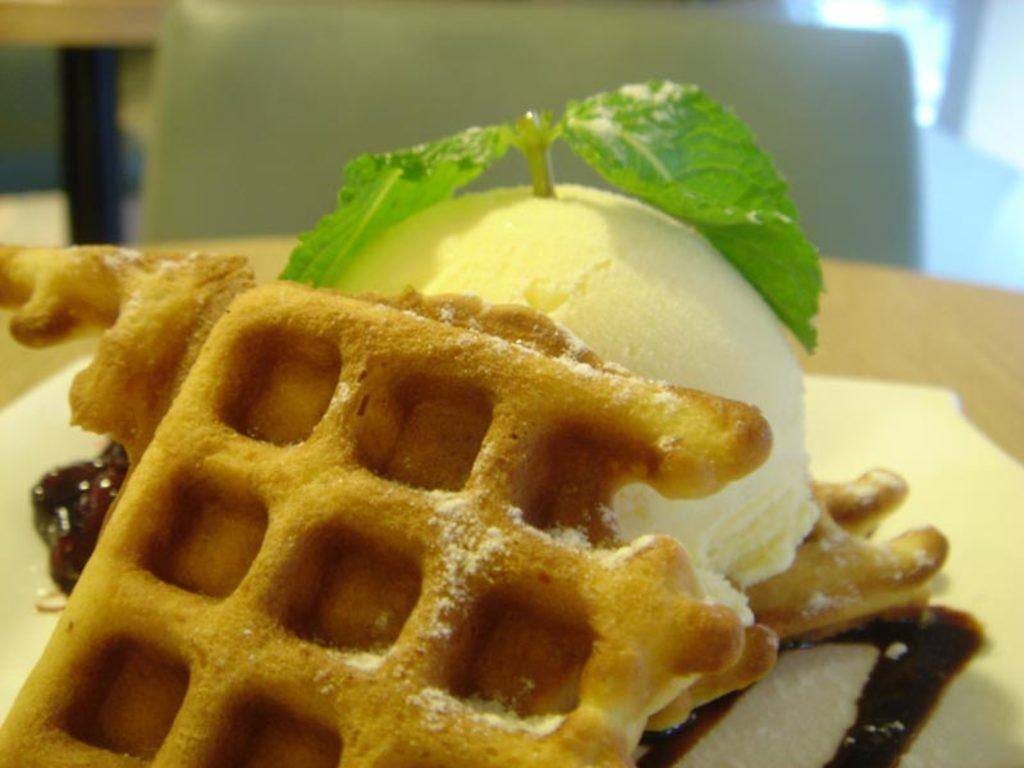What type of dessert is present in the image? There is ice cream in the image. What type of plant material is visible in the image? There are vegetable leaves in the image. What category of items can be seen in the image? There is food in the image. What type of furniture is present in the image? There is a chair in the image. What type of juice is being served in the image? There is no juice present in the image. Can you describe the parent-child relationship in the image? There is no parent or child present in the image. 